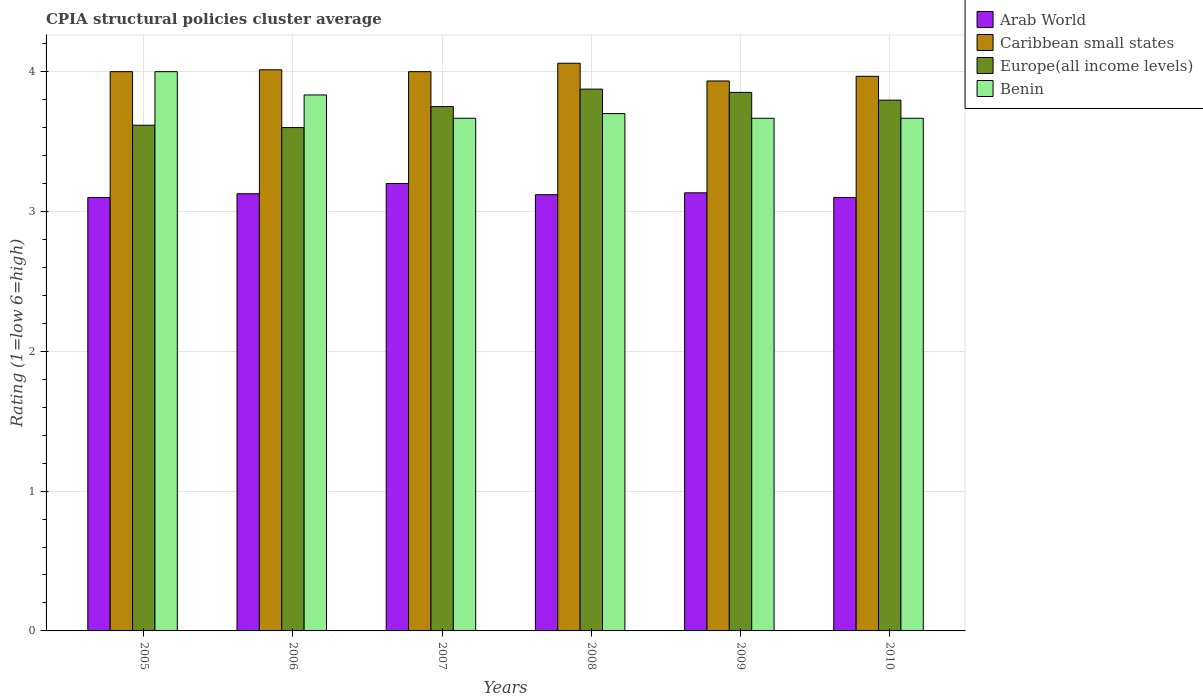How many different coloured bars are there?
Your answer should be very brief. 4. How many groups of bars are there?
Make the answer very short. 6. Are the number of bars per tick equal to the number of legend labels?
Keep it short and to the point. Yes. Are the number of bars on each tick of the X-axis equal?
Give a very brief answer. Yes. What is the label of the 2nd group of bars from the left?
Provide a succinct answer. 2006. In how many cases, is the number of bars for a given year not equal to the number of legend labels?
Your response must be concise. 0. Across all years, what is the maximum CPIA rating in Caribbean small states?
Offer a terse response. 4.06. Across all years, what is the minimum CPIA rating in Europe(all income levels)?
Provide a short and direct response. 3.6. In which year was the CPIA rating in Caribbean small states maximum?
Make the answer very short. 2008. In which year was the CPIA rating in Arab World minimum?
Offer a terse response. 2005. What is the total CPIA rating in Benin in the graph?
Provide a short and direct response. 22.53. What is the difference between the CPIA rating in Europe(all income levels) in 2005 and that in 2008?
Give a very brief answer. -0.26. What is the difference between the CPIA rating in Benin in 2005 and the CPIA rating in Arab World in 2009?
Ensure brevity in your answer.  0.87. What is the average CPIA rating in Europe(all income levels) per year?
Provide a succinct answer. 3.75. In the year 2008, what is the difference between the CPIA rating in Caribbean small states and CPIA rating in Benin?
Provide a succinct answer. 0.36. What is the ratio of the CPIA rating in Benin in 2005 to that in 2006?
Give a very brief answer. 1.04. What is the difference between the highest and the second highest CPIA rating in Europe(all income levels)?
Offer a very short reply. 0.02. What is the difference between the highest and the lowest CPIA rating in Caribbean small states?
Keep it short and to the point. 0.13. Is the sum of the CPIA rating in Caribbean small states in 2009 and 2010 greater than the maximum CPIA rating in Europe(all income levels) across all years?
Ensure brevity in your answer.  Yes. Is it the case that in every year, the sum of the CPIA rating in Benin and CPIA rating in Arab World is greater than the sum of CPIA rating in Europe(all income levels) and CPIA rating in Caribbean small states?
Give a very brief answer. No. What does the 4th bar from the left in 2005 represents?
Keep it short and to the point. Benin. What does the 4th bar from the right in 2006 represents?
Your response must be concise. Arab World. Is it the case that in every year, the sum of the CPIA rating in Arab World and CPIA rating in Europe(all income levels) is greater than the CPIA rating in Caribbean small states?
Offer a terse response. Yes. What is the difference between two consecutive major ticks on the Y-axis?
Ensure brevity in your answer.  1. Does the graph contain any zero values?
Your response must be concise. No. Does the graph contain grids?
Your answer should be very brief. Yes. Where does the legend appear in the graph?
Offer a very short reply. Top right. How many legend labels are there?
Make the answer very short. 4. How are the legend labels stacked?
Offer a very short reply. Vertical. What is the title of the graph?
Keep it short and to the point. CPIA structural policies cluster average. What is the label or title of the X-axis?
Provide a short and direct response. Years. What is the Rating (1=low 6=high) of Arab World in 2005?
Your answer should be compact. 3.1. What is the Rating (1=low 6=high) in Europe(all income levels) in 2005?
Provide a short and direct response. 3.62. What is the Rating (1=low 6=high) in Arab World in 2006?
Give a very brief answer. 3.13. What is the Rating (1=low 6=high) in Caribbean small states in 2006?
Your answer should be compact. 4.01. What is the Rating (1=low 6=high) of Benin in 2006?
Your response must be concise. 3.83. What is the Rating (1=low 6=high) in Caribbean small states in 2007?
Offer a very short reply. 4. What is the Rating (1=low 6=high) of Europe(all income levels) in 2007?
Your answer should be very brief. 3.75. What is the Rating (1=low 6=high) in Benin in 2007?
Make the answer very short. 3.67. What is the Rating (1=low 6=high) of Arab World in 2008?
Keep it short and to the point. 3.12. What is the Rating (1=low 6=high) of Caribbean small states in 2008?
Give a very brief answer. 4.06. What is the Rating (1=low 6=high) of Europe(all income levels) in 2008?
Provide a succinct answer. 3.88. What is the Rating (1=low 6=high) of Arab World in 2009?
Provide a succinct answer. 3.13. What is the Rating (1=low 6=high) in Caribbean small states in 2009?
Give a very brief answer. 3.93. What is the Rating (1=low 6=high) in Europe(all income levels) in 2009?
Offer a very short reply. 3.85. What is the Rating (1=low 6=high) in Benin in 2009?
Provide a succinct answer. 3.67. What is the Rating (1=low 6=high) in Caribbean small states in 2010?
Your response must be concise. 3.97. What is the Rating (1=low 6=high) in Europe(all income levels) in 2010?
Offer a terse response. 3.8. What is the Rating (1=low 6=high) in Benin in 2010?
Make the answer very short. 3.67. Across all years, what is the maximum Rating (1=low 6=high) of Caribbean small states?
Make the answer very short. 4.06. Across all years, what is the maximum Rating (1=low 6=high) of Europe(all income levels)?
Ensure brevity in your answer.  3.88. Across all years, what is the maximum Rating (1=low 6=high) in Benin?
Your answer should be compact. 4. Across all years, what is the minimum Rating (1=low 6=high) in Caribbean small states?
Give a very brief answer. 3.93. Across all years, what is the minimum Rating (1=low 6=high) in Europe(all income levels)?
Provide a succinct answer. 3.6. Across all years, what is the minimum Rating (1=low 6=high) of Benin?
Offer a very short reply. 3.67. What is the total Rating (1=low 6=high) of Arab World in the graph?
Your response must be concise. 18.78. What is the total Rating (1=low 6=high) in Caribbean small states in the graph?
Ensure brevity in your answer.  23.97. What is the total Rating (1=low 6=high) in Europe(all income levels) in the graph?
Offer a very short reply. 22.49. What is the total Rating (1=low 6=high) of Benin in the graph?
Give a very brief answer. 22.53. What is the difference between the Rating (1=low 6=high) in Arab World in 2005 and that in 2006?
Give a very brief answer. -0.03. What is the difference between the Rating (1=low 6=high) of Caribbean small states in 2005 and that in 2006?
Provide a succinct answer. -0.01. What is the difference between the Rating (1=low 6=high) in Europe(all income levels) in 2005 and that in 2006?
Your answer should be compact. 0.02. What is the difference between the Rating (1=low 6=high) of Europe(all income levels) in 2005 and that in 2007?
Offer a terse response. -0.13. What is the difference between the Rating (1=low 6=high) in Benin in 2005 and that in 2007?
Ensure brevity in your answer.  0.33. What is the difference between the Rating (1=low 6=high) in Arab World in 2005 and that in 2008?
Your answer should be very brief. -0.02. What is the difference between the Rating (1=low 6=high) in Caribbean small states in 2005 and that in 2008?
Provide a succinct answer. -0.06. What is the difference between the Rating (1=low 6=high) in Europe(all income levels) in 2005 and that in 2008?
Offer a terse response. -0.26. What is the difference between the Rating (1=low 6=high) in Benin in 2005 and that in 2008?
Provide a succinct answer. 0.3. What is the difference between the Rating (1=low 6=high) of Arab World in 2005 and that in 2009?
Your response must be concise. -0.03. What is the difference between the Rating (1=low 6=high) of Caribbean small states in 2005 and that in 2009?
Offer a very short reply. 0.07. What is the difference between the Rating (1=low 6=high) in Europe(all income levels) in 2005 and that in 2009?
Make the answer very short. -0.24. What is the difference between the Rating (1=low 6=high) in Benin in 2005 and that in 2009?
Offer a very short reply. 0.33. What is the difference between the Rating (1=low 6=high) of Arab World in 2005 and that in 2010?
Ensure brevity in your answer.  0. What is the difference between the Rating (1=low 6=high) in Caribbean small states in 2005 and that in 2010?
Provide a succinct answer. 0.03. What is the difference between the Rating (1=low 6=high) of Europe(all income levels) in 2005 and that in 2010?
Keep it short and to the point. -0.18. What is the difference between the Rating (1=low 6=high) of Arab World in 2006 and that in 2007?
Your answer should be compact. -0.07. What is the difference between the Rating (1=low 6=high) of Caribbean small states in 2006 and that in 2007?
Your answer should be very brief. 0.01. What is the difference between the Rating (1=low 6=high) of Europe(all income levels) in 2006 and that in 2007?
Offer a terse response. -0.15. What is the difference between the Rating (1=low 6=high) in Arab World in 2006 and that in 2008?
Provide a short and direct response. 0.01. What is the difference between the Rating (1=low 6=high) of Caribbean small states in 2006 and that in 2008?
Give a very brief answer. -0.05. What is the difference between the Rating (1=low 6=high) in Europe(all income levels) in 2006 and that in 2008?
Offer a terse response. -0.28. What is the difference between the Rating (1=low 6=high) of Benin in 2006 and that in 2008?
Your response must be concise. 0.13. What is the difference between the Rating (1=low 6=high) in Arab World in 2006 and that in 2009?
Your response must be concise. -0.01. What is the difference between the Rating (1=low 6=high) of Europe(all income levels) in 2006 and that in 2009?
Offer a very short reply. -0.25. What is the difference between the Rating (1=low 6=high) of Arab World in 2006 and that in 2010?
Keep it short and to the point. 0.03. What is the difference between the Rating (1=low 6=high) in Caribbean small states in 2006 and that in 2010?
Provide a short and direct response. 0.05. What is the difference between the Rating (1=low 6=high) in Europe(all income levels) in 2006 and that in 2010?
Offer a very short reply. -0.2. What is the difference between the Rating (1=low 6=high) in Arab World in 2007 and that in 2008?
Your answer should be very brief. 0.08. What is the difference between the Rating (1=low 6=high) of Caribbean small states in 2007 and that in 2008?
Offer a terse response. -0.06. What is the difference between the Rating (1=low 6=high) of Europe(all income levels) in 2007 and that in 2008?
Make the answer very short. -0.12. What is the difference between the Rating (1=low 6=high) of Benin in 2007 and that in 2008?
Give a very brief answer. -0.03. What is the difference between the Rating (1=low 6=high) of Arab World in 2007 and that in 2009?
Ensure brevity in your answer.  0.07. What is the difference between the Rating (1=low 6=high) of Caribbean small states in 2007 and that in 2009?
Offer a very short reply. 0.07. What is the difference between the Rating (1=low 6=high) of Europe(all income levels) in 2007 and that in 2009?
Offer a very short reply. -0.1. What is the difference between the Rating (1=low 6=high) of Europe(all income levels) in 2007 and that in 2010?
Offer a terse response. -0.05. What is the difference between the Rating (1=low 6=high) in Benin in 2007 and that in 2010?
Your answer should be compact. 0. What is the difference between the Rating (1=low 6=high) in Arab World in 2008 and that in 2009?
Offer a very short reply. -0.01. What is the difference between the Rating (1=low 6=high) of Caribbean small states in 2008 and that in 2009?
Offer a very short reply. 0.13. What is the difference between the Rating (1=low 6=high) of Europe(all income levels) in 2008 and that in 2009?
Provide a succinct answer. 0.02. What is the difference between the Rating (1=low 6=high) in Caribbean small states in 2008 and that in 2010?
Ensure brevity in your answer.  0.09. What is the difference between the Rating (1=low 6=high) of Europe(all income levels) in 2008 and that in 2010?
Ensure brevity in your answer.  0.08. What is the difference between the Rating (1=low 6=high) of Benin in 2008 and that in 2010?
Ensure brevity in your answer.  0.03. What is the difference between the Rating (1=low 6=high) in Arab World in 2009 and that in 2010?
Your answer should be very brief. 0.03. What is the difference between the Rating (1=low 6=high) in Caribbean small states in 2009 and that in 2010?
Ensure brevity in your answer.  -0.03. What is the difference between the Rating (1=low 6=high) of Europe(all income levels) in 2009 and that in 2010?
Keep it short and to the point. 0.06. What is the difference between the Rating (1=low 6=high) of Arab World in 2005 and the Rating (1=low 6=high) of Caribbean small states in 2006?
Your answer should be compact. -0.91. What is the difference between the Rating (1=low 6=high) in Arab World in 2005 and the Rating (1=low 6=high) in Europe(all income levels) in 2006?
Your answer should be compact. -0.5. What is the difference between the Rating (1=low 6=high) in Arab World in 2005 and the Rating (1=low 6=high) in Benin in 2006?
Keep it short and to the point. -0.73. What is the difference between the Rating (1=low 6=high) of Caribbean small states in 2005 and the Rating (1=low 6=high) of Europe(all income levels) in 2006?
Keep it short and to the point. 0.4. What is the difference between the Rating (1=low 6=high) in Europe(all income levels) in 2005 and the Rating (1=low 6=high) in Benin in 2006?
Provide a succinct answer. -0.22. What is the difference between the Rating (1=low 6=high) of Arab World in 2005 and the Rating (1=low 6=high) of Europe(all income levels) in 2007?
Offer a very short reply. -0.65. What is the difference between the Rating (1=low 6=high) of Arab World in 2005 and the Rating (1=low 6=high) of Benin in 2007?
Provide a succinct answer. -0.57. What is the difference between the Rating (1=low 6=high) in Caribbean small states in 2005 and the Rating (1=low 6=high) in Europe(all income levels) in 2007?
Offer a terse response. 0.25. What is the difference between the Rating (1=low 6=high) of Europe(all income levels) in 2005 and the Rating (1=low 6=high) of Benin in 2007?
Provide a short and direct response. -0.05. What is the difference between the Rating (1=low 6=high) of Arab World in 2005 and the Rating (1=low 6=high) of Caribbean small states in 2008?
Provide a succinct answer. -0.96. What is the difference between the Rating (1=low 6=high) in Arab World in 2005 and the Rating (1=low 6=high) in Europe(all income levels) in 2008?
Keep it short and to the point. -0.78. What is the difference between the Rating (1=low 6=high) of Arab World in 2005 and the Rating (1=low 6=high) of Benin in 2008?
Keep it short and to the point. -0.6. What is the difference between the Rating (1=low 6=high) of Caribbean small states in 2005 and the Rating (1=low 6=high) of Benin in 2008?
Offer a terse response. 0.3. What is the difference between the Rating (1=low 6=high) of Europe(all income levels) in 2005 and the Rating (1=low 6=high) of Benin in 2008?
Your response must be concise. -0.08. What is the difference between the Rating (1=low 6=high) of Arab World in 2005 and the Rating (1=low 6=high) of Caribbean small states in 2009?
Give a very brief answer. -0.83. What is the difference between the Rating (1=low 6=high) of Arab World in 2005 and the Rating (1=low 6=high) of Europe(all income levels) in 2009?
Give a very brief answer. -0.75. What is the difference between the Rating (1=low 6=high) of Arab World in 2005 and the Rating (1=low 6=high) of Benin in 2009?
Your response must be concise. -0.57. What is the difference between the Rating (1=low 6=high) of Caribbean small states in 2005 and the Rating (1=low 6=high) of Europe(all income levels) in 2009?
Provide a succinct answer. 0.15. What is the difference between the Rating (1=low 6=high) of Arab World in 2005 and the Rating (1=low 6=high) of Caribbean small states in 2010?
Provide a short and direct response. -0.87. What is the difference between the Rating (1=low 6=high) of Arab World in 2005 and the Rating (1=low 6=high) of Europe(all income levels) in 2010?
Provide a short and direct response. -0.7. What is the difference between the Rating (1=low 6=high) in Arab World in 2005 and the Rating (1=low 6=high) in Benin in 2010?
Your answer should be compact. -0.57. What is the difference between the Rating (1=low 6=high) in Caribbean small states in 2005 and the Rating (1=low 6=high) in Europe(all income levels) in 2010?
Offer a terse response. 0.2. What is the difference between the Rating (1=low 6=high) of Caribbean small states in 2005 and the Rating (1=low 6=high) of Benin in 2010?
Provide a succinct answer. 0.33. What is the difference between the Rating (1=low 6=high) in Europe(all income levels) in 2005 and the Rating (1=low 6=high) in Benin in 2010?
Provide a short and direct response. -0.05. What is the difference between the Rating (1=low 6=high) of Arab World in 2006 and the Rating (1=low 6=high) of Caribbean small states in 2007?
Your answer should be very brief. -0.87. What is the difference between the Rating (1=low 6=high) in Arab World in 2006 and the Rating (1=low 6=high) in Europe(all income levels) in 2007?
Your answer should be very brief. -0.62. What is the difference between the Rating (1=low 6=high) of Arab World in 2006 and the Rating (1=low 6=high) of Benin in 2007?
Make the answer very short. -0.54. What is the difference between the Rating (1=low 6=high) in Caribbean small states in 2006 and the Rating (1=low 6=high) in Europe(all income levels) in 2007?
Provide a succinct answer. 0.26. What is the difference between the Rating (1=low 6=high) in Caribbean small states in 2006 and the Rating (1=low 6=high) in Benin in 2007?
Offer a terse response. 0.35. What is the difference between the Rating (1=low 6=high) of Europe(all income levels) in 2006 and the Rating (1=low 6=high) of Benin in 2007?
Offer a very short reply. -0.07. What is the difference between the Rating (1=low 6=high) in Arab World in 2006 and the Rating (1=low 6=high) in Caribbean small states in 2008?
Ensure brevity in your answer.  -0.93. What is the difference between the Rating (1=low 6=high) in Arab World in 2006 and the Rating (1=low 6=high) in Europe(all income levels) in 2008?
Ensure brevity in your answer.  -0.75. What is the difference between the Rating (1=low 6=high) of Arab World in 2006 and the Rating (1=low 6=high) of Benin in 2008?
Offer a very short reply. -0.57. What is the difference between the Rating (1=low 6=high) of Caribbean small states in 2006 and the Rating (1=low 6=high) of Europe(all income levels) in 2008?
Offer a terse response. 0.14. What is the difference between the Rating (1=low 6=high) of Caribbean small states in 2006 and the Rating (1=low 6=high) of Benin in 2008?
Offer a very short reply. 0.31. What is the difference between the Rating (1=low 6=high) of Arab World in 2006 and the Rating (1=low 6=high) of Caribbean small states in 2009?
Your answer should be compact. -0.81. What is the difference between the Rating (1=low 6=high) of Arab World in 2006 and the Rating (1=low 6=high) of Europe(all income levels) in 2009?
Provide a short and direct response. -0.73. What is the difference between the Rating (1=low 6=high) in Arab World in 2006 and the Rating (1=low 6=high) in Benin in 2009?
Ensure brevity in your answer.  -0.54. What is the difference between the Rating (1=low 6=high) of Caribbean small states in 2006 and the Rating (1=low 6=high) of Europe(all income levels) in 2009?
Give a very brief answer. 0.16. What is the difference between the Rating (1=low 6=high) of Caribbean small states in 2006 and the Rating (1=low 6=high) of Benin in 2009?
Your response must be concise. 0.35. What is the difference between the Rating (1=low 6=high) in Europe(all income levels) in 2006 and the Rating (1=low 6=high) in Benin in 2009?
Provide a short and direct response. -0.07. What is the difference between the Rating (1=low 6=high) of Arab World in 2006 and the Rating (1=low 6=high) of Caribbean small states in 2010?
Your response must be concise. -0.84. What is the difference between the Rating (1=low 6=high) of Arab World in 2006 and the Rating (1=low 6=high) of Europe(all income levels) in 2010?
Your response must be concise. -0.67. What is the difference between the Rating (1=low 6=high) in Arab World in 2006 and the Rating (1=low 6=high) in Benin in 2010?
Your response must be concise. -0.54. What is the difference between the Rating (1=low 6=high) of Caribbean small states in 2006 and the Rating (1=low 6=high) of Europe(all income levels) in 2010?
Make the answer very short. 0.22. What is the difference between the Rating (1=low 6=high) in Caribbean small states in 2006 and the Rating (1=low 6=high) in Benin in 2010?
Your answer should be very brief. 0.35. What is the difference between the Rating (1=low 6=high) in Europe(all income levels) in 2006 and the Rating (1=low 6=high) in Benin in 2010?
Offer a terse response. -0.07. What is the difference between the Rating (1=low 6=high) in Arab World in 2007 and the Rating (1=low 6=high) in Caribbean small states in 2008?
Give a very brief answer. -0.86. What is the difference between the Rating (1=low 6=high) in Arab World in 2007 and the Rating (1=low 6=high) in Europe(all income levels) in 2008?
Your answer should be compact. -0.68. What is the difference between the Rating (1=low 6=high) in Arab World in 2007 and the Rating (1=low 6=high) in Benin in 2008?
Offer a very short reply. -0.5. What is the difference between the Rating (1=low 6=high) in Arab World in 2007 and the Rating (1=low 6=high) in Caribbean small states in 2009?
Provide a succinct answer. -0.73. What is the difference between the Rating (1=low 6=high) in Arab World in 2007 and the Rating (1=low 6=high) in Europe(all income levels) in 2009?
Keep it short and to the point. -0.65. What is the difference between the Rating (1=low 6=high) of Arab World in 2007 and the Rating (1=low 6=high) of Benin in 2009?
Your response must be concise. -0.47. What is the difference between the Rating (1=low 6=high) in Caribbean small states in 2007 and the Rating (1=low 6=high) in Europe(all income levels) in 2009?
Provide a short and direct response. 0.15. What is the difference between the Rating (1=low 6=high) in Caribbean small states in 2007 and the Rating (1=low 6=high) in Benin in 2009?
Your answer should be compact. 0.33. What is the difference between the Rating (1=low 6=high) of Europe(all income levels) in 2007 and the Rating (1=low 6=high) of Benin in 2009?
Ensure brevity in your answer.  0.08. What is the difference between the Rating (1=low 6=high) in Arab World in 2007 and the Rating (1=low 6=high) in Caribbean small states in 2010?
Your response must be concise. -0.77. What is the difference between the Rating (1=low 6=high) of Arab World in 2007 and the Rating (1=low 6=high) of Europe(all income levels) in 2010?
Ensure brevity in your answer.  -0.6. What is the difference between the Rating (1=low 6=high) in Arab World in 2007 and the Rating (1=low 6=high) in Benin in 2010?
Give a very brief answer. -0.47. What is the difference between the Rating (1=low 6=high) of Caribbean small states in 2007 and the Rating (1=low 6=high) of Europe(all income levels) in 2010?
Keep it short and to the point. 0.2. What is the difference between the Rating (1=low 6=high) in Europe(all income levels) in 2007 and the Rating (1=low 6=high) in Benin in 2010?
Ensure brevity in your answer.  0.08. What is the difference between the Rating (1=low 6=high) of Arab World in 2008 and the Rating (1=low 6=high) of Caribbean small states in 2009?
Your answer should be compact. -0.81. What is the difference between the Rating (1=low 6=high) of Arab World in 2008 and the Rating (1=low 6=high) of Europe(all income levels) in 2009?
Your answer should be compact. -0.73. What is the difference between the Rating (1=low 6=high) of Arab World in 2008 and the Rating (1=low 6=high) of Benin in 2009?
Provide a short and direct response. -0.55. What is the difference between the Rating (1=low 6=high) of Caribbean small states in 2008 and the Rating (1=low 6=high) of Europe(all income levels) in 2009?
Provide a short and direct response. 0.21. What is the difference between the Rating (1=low 6=high) in Caribbean small states in 2008 and the Rating (1=low 6=high) in Benin in 2009?
Ensure brevity in your answer.  0.39. What is the difference between the Rating (1=low 6=high) in Europe(all income levels) in 2008 and the Rating (1=low 6=high) in Benin in 2009?
Make the answer very short. 0.21. What is the difference between the Rating (1=low 6=high) of Arab World in 2008 and the Rating (1=low 6=high) of Caribbean small states in 2010?
Your answer should be compact. -0.85. What is the difference between the Rating (1=low 6=high) of Arab World in 2008 and the Rating (1=low 6=high) of Europe(all income levels) in 2010?
Ensure brevity in your answer.  -0.68. What is the difference between the Rating (1=low 6=high) in Arab World in 2008 and the Rating (1=low 6=high) in Benin in 2010?
Offer a terse response. -0.55. What is the difference between the Rating (1=low 6=high) of Caribbean small states in 2008 and the Rating (1=low 6=high) of Europe(all income levels) in 2010?
Offer a terse response. 0.26. What is the difference between the Rating (1=low 6=high) of Caribbean small states in 2008 and the Rating (1=low 6=high) of Benin in 2010?
Your answer should be very brief. 0.39. What is the difference between the Rating (1=low 6=high) of Europe(all income levels) in 2008 and the Rating (1=low 6=high) of Benin in 2010?
Keep it short and to the point. 0.21. What is the difference between the Rating (1=low 6=high) of Arab World in 2009 and the Rating (1=low 6=high) of Europe(all income levels) in 2010?
Offer a terse response. -0.66. What is the difference between the Rating (1=low 6=high) of Arab World in 2009 and the Rating (1=low 6=high) of Benin in 2010?
Give a very brief answer. -0.53. What is the difference between the Rating (1=low 6=high) in Caribbean small states in 2009 and the Rating (1=low 6=high) in Europe(all income levels) in 2010?
Your response must be concise. 0.14. What is the difference between the Rating (1=low 6=high) in Caribbean small states in 2009 and the Rating (1=low 6=high) in Benin in 2010?
Make the answer very short. 0.27. What is the difference between the Rating (1=low 6=high) of Europe(all income levels) in 2009 and the Rating (1=low 6=high) of Benin in 2010?
Offer a very short reply. 0.19. What is the average Rating (1=low 6=high) in Arab World per year?
Your answer should be very brief. 3.13. What is the average Rating (1=low 6=high) of Caribbean small states per year?
Your answer should be very brief. 4. What is the average Rating (1=low 6=high) of Europe(all income levels) per year?
Your answer should be very brief. 3.75. What is the average Rating (1=low 6=high) of Benin per year?
Make the answer very short. 3.76. In the year 2005, what is the difference between the Rating (1=low 6=high) of Arab World and Rating (1=low 6=high) of Europe(all income levels)?
Your answer should be very brief. -0.52. In the year 2005, what is the difference between the Rating (1=low 6=high) of Arab World and Rating (1=low 6=high) of Benin?
Provide a short and direct response. -0.9. In the year 2005, what is the difference between the Rating (1=low 6=high) in Caribbean small states and Rating (1=low 6=high) in Europe(all income levels)?
Your answer should be compact. 0.38. In the year 2005, what is the difference between the Rating (1=low 6=high) of Europe(all income levels) and Rating (1=low 6=high) of Benin?
Give a very brief answer. -0.38. In the year 2006, what is the difference between the Rating (1=low 6=high) in Arab World and Rating (1=low 6=high) in Caribbean small states?
Keep it short and to the point. -0.89. In the year 2006, what is the difference between the Rating (1=low 6=high) in Arab World and Rating (1=low 6=high) in Europe(all income levels)?
Your response must be concise. -0.47. In the year 2006, what is the difference between the Rating (1=low 6=high) of Arab World and Rating (1=low 6=high) of Benin?
Ensure brevity in your answer.  -0.71. In the year 2006, what is the difference between the Rating (1=low 6=high) of Caribbean small states and Rating (1=low 6=high) of Europe(all income levels)?
Offer a very short reply. 0.41. In the year 2006, what is the difference between the Rating (1=low 6=high) of Caribbean small states and Rating (1=low 6=high) of Benin?
Offer a very short reply. 0.18. In the year 2006, what is the difference between the Rating (1=low 6=high) in Europe(all income levels) and Rating (1=low 6=high) in Benin?
Provide a short and direct response. -0.23. In the year 2007, what is the difference between the Rating (1=low 6=high) in Arab World and Rating (1=low 6=high) in Europe(all income levels)?
Ensure brevity in your answer.  -0.55. In the year 2007, what is the difference between the Rating (1=low 6=high) of Arab World and Rating (1=low 6=high) of Benin?
Keep it short and to the point. -0.47. In the year 2007, what is the difference between the Rating (1=low 6=high) in Caribbean small states and Rating (1=low 6=high) in Benin?
Your response must be concise. 0.33. In the year 2007, what is the difference between the Rating (1=low 6=high) in Europe(all income levels) and Rating (1=low 6=high) in Benin?
Your answer should be compact. 0.08. In the year 2008, what is the difference between the Rating (1=low 6=high) in Arab World and Rating (1=low 6=high) in Caribbean small states?
Offer a terse response. -0.94. In the year 2008, what is the difference between the Rating (1=low 6=high) of Arab World and Rating (1=low 6=high) of Europe(all income levels)?
Offer a very short reply. -0.76. In the year 2008, what is the difference between the Rating (1=low 6=high) in Arab World and Rating (1=low 6=high) in Benin?
Offer a very short reply. -0.58. In the year 2008, what is the difference between the Rating (1=low 6=high) of Caribbean small states and Rating (1=low 6=high) of Europe(all income levels)?
Provide a short and direct response. 0.18. In the year 2008, what is the difference between the Rating (1=low 6=high) of Caribbean small states and Rating (1=low 6=high) of Benin?
Ensure brevity in your answer.  0.36. In the year 2008, what is the difference between the Rating (1=low 6=high) in Europe(all income levels) and Rating (1=low 6=high) in Benin?
Your response must be concise. 0.17. In the year 2009, what is the difference between the Rating (1=low 6=high) of Arab World and Rating (1=low 6=high) of Europe(all income levels)?
Your response must be concise. -0.72. In the year 2009, what is the difference between the Rating (1=low 6=high) in Arab World and Rating (1=low 6=high) in Benin?
Your answer should be compact. -0.53. In the year 2009, what is the difference between the Rating (1=low 6=high) of Caribbean small states and Rating (1=low 6=high) of Europe(all income levels)?
Offer a very short reply. 0.08. In the year 2009, what is the difference between the Rating (1=low 6=high) of Caribbean small states and Rating (1=low 6=high) of Benin?
Give a very brief answer. 0.27. In the year 2009, what is the difference between the Rating (1=low 6=high) of Europe(all income levels) and Rating (1=low 6=high) of Benin?
Your response must be concise. 0.19. In the year 2010, what is the difference between the Rating (1=low 6=high) of Arab World and Rating (1=low 6=high) of Caribbean small states?
Your answer should be very brief. -0.87. In the year 2010, what is the difference between the Rating (1=low 6=high) of Arab World and Rating (1=low 6=high) of Europe(all income levels)?
Provide a short and direct response. -0.7. In the year 2010, what is the difference between the Rating (1=low 6=high) in Arab World and Rating (1=low 6=high) in Benin?
Give a very brief answer. -0.57. In the year 2010, what is the difference between the Rating (1=low 6=high) in Caribbean small states and Rating (1=low 6=high) in Europe(all income levels)?
Give a very brief answer. 0.17. In the year 2010, what is the difference between the Rating (1=low 6=high) of Caribbean small states and Rating (1=low 6=high) of Benin?
Your response must be concise. 0.3. In the year 2010, what is the difference between the Rating (1=low 6=high) of Europe(all income levels) and Rating (1=low 6=high) of Benin?
Your answer should be very brief. 0.13. What is the ratio of the Rating (1=low 6=high) of Benin in 2005 to that in 2006?
Offer a very short reply. 1.04. What is the ratio of the Rating (1=low 6=high) of Arab World in 2005 to that in 2007?
Ensure brevity in your answer.  0.97. What is the ratio of the Rating (1=low 6=high) in Caribbean small states in 2005 to that in 2007?
Your answer should be compact. 1. What is the ratio of the Rating (1=low 6=high) of Europe(all income levels) in 2005 to that in 2007?
Make the answer very short. 0.96. What is the ratio of the Rating (1=low 6=high) of Arab World in 2005 to that in 2008?
Make the answer very short. 0.99. What is the ratio of the Rating (1=low 6=high) of Caribbean small states in 2005 to that in 2008?
Offer a terse response. 0.99. What is the ratio of the Rating (1=low 6=high) of Europe(all income levels) in 2005 to that in 2008?
Your answer should be very brief. 0.93. What is the ratio of the Rating (1=low 6=high) of Benin in 2005 to that in 2008?
Provide a succinct answer. 1.08. What is the ratio of the Rating (1=low 6=high) in Arab World in 2005 to that in 2009?
Provide a short and direct response. 0.99. What is the ratio of the Rating (1=low 6=high) in Caribbean small states in 2005 to that in 2009?
Give a very brief answer. 1.02. What is the ratio of the Rating (1=low 6=high) in Europe(all income levels) in 2005 to that in 2009?
Ensure brevity in your answer.  0.94. What is the ratio of the Rating (1=low 6=high) in Benin in 2005 to that in 2009?
Provide a short and direct response. 1.09. What is the ratio of the Rating (1=low 6=high) of Caribbean small states in 2005 to that in 2010?
Your response must be concise. 1.01. What is the ratio of the Rating (1=low 6=high) in Europe(all income levels) in 2005 to that in 2010?
Provide a short and direct response. 0.95. What is the ratio of the Rating (1=low 6=high) in Benin in 2005 to that in 2010?
Your response must be concise. 1.09. What is the ratio of the Rating (1=low 6=high) in Arab World in 2006 to that in 2007?
Your answer should be very brief. 0.98. What is the ratio of the Rating (1=low 6=high) in Europe(all income levels) in 2006 to that in 2007?
Give a very brief answer. 0.96. What is the ratio of the Rating (1=low 6=high) of Benin in 2006 to that in 2007?
Provide a succinct answer. 1.05. What is the ratio of the Rating (1=low 6=high) in Arab World in 2006 to that in 2008?
Your response must be concise. 1. What is the ratio of the Rating (1=low 6=high) in Caribbean small states in 2006 to that in 2008?
Provide a succinct answer. 0.99. What is the ratio of the Rating (1=low 6=high) of Europe(all income levels) in 2006 to that in 2008?
Keep it short and to the point. 0.93. What is the ratio of the Rating (1=low 6=high) in Benin in 2006 to that in 2008?
Offer a very short reply. 1.04. What is the ratio of the Rating (1=low 6=high) of Caribbean small states in 2006 to that in 2009?
Provide a short and direct response. 1.02. What is the ratio of the Rating (1=low 6=high) in Europe(all income levels) in 2006 to that in 2009?
Make the answer very short. 0.93. What is the ratio of the Rating (1=low 6=high) of Benin in 2006 to that in 2009?
Provide a succinct answer. 1.05. What is the ratio of the Rating (1=low 6=high) of Arab World in 2006 to that in 2010?
Your answer should be compact. 1.01. What is the ratio of the Rating (1=low 6=high) of Caribbean small states in 2006 to that in 2010?
Keep it short and to the point. 1.01. What is the ratio of the Rating (1=low 6=high) of Europe(all income levels) in 2006 to that in 2010?
Keep it short and to the point. 0.95. What is the ratio of the Rating (1=low 6=high) in Benin in 2006 to that in 2010?
Offer a terse response. 1.05. What is the ratio of the Rating (1=low 6=high) in Arab World in 2007 to that in 2008?
Your response must be concise. 1.03. What is the ratio of the Rating (1=low 6=high) in Caribbean small states in 2007 to that in 2008?
Make the answer very short. 0.99. What is the ratio of the Rating (1=low 6=high) of Benin in 2007 to that in 2008?
Your answer should be very brief. 0.99. What is the ratio of the Rating (1=low 6=high) in Arab World in 2007 to that in 2009?
Give a very brief answer. 1.02. What is the ratio of the Rating (1=low 6=high) of Caribbean small states in 2007 to that in 2009?
Provide a short and direct response. 1.02. What is the ratio of the Rating (1=low 6=high) of Europe(all income levels) in 2007 to that in 2009?
Give a very brief answer. 0.97. What is the ratio of the Rating (1=low 6=high) in Benin in 2007 to that in 2009?
Offer a very short reply. 1. What is the ratio of the Rating (1=low 6=high) in Arab World in 2007 to that in 2010?
Offer a very short reply. 1.03. What is the ratio of the Rating (1=low 6=high) in Caribbean small states in 2007 to that in 2010?
Your response must be concise. 1.01. What is the ratio of the Rating (1=low 6=high) in Europe(all income levels) in 2007 to that in 2010?
Your answer should be compact. 0.99. What is the ratio of the Rating (1=low 6=high) of Arab World in 2008 to that in 2009?
Provide a short and direct response. 1. What is the ratio of the Rating (1=low 6=high) in Caribbean small states in 2008 to that in 2009?
Your response must be concise. 1.03. What is the ratio of the Rating (1=low 6=high) in Benin in 2008 to that in 2009?
Keep it short and to the point. 1.01. What is the ratio of the Rating (1=low 6=high) in Arab World in 2008 to that in 2010?
Offer a terse response. 1.01. What is the ratio of the Rating (1=low 6=high) of Caribbean small states in 2008 to that in 2010?
Provide a short and direct response. 1.02. What is the ratio of the Rating (1=low 6=high) in Europe(all income levels) in 2008 to that in 2010?
Your answer should be very brief. 1.02. What is the ratio of the Rating (1=low 6=high) in Benin in 2008 to that in 2010?
Your answer should be very brief. 1.01. What is the ratio of the Rating (1=low 6=high) of Arab World in 2009 to that in 2010?
Ensure brevity in your answer.  1.01. What is the ratio of the Rating (1=low 6=high) of Europe(all income levels) in 2009 to that in 2010?
Provide a short and direct response. 1.01. What is the difference between the highest and the second highest Rating (1=low 6=high) in Arab World?
Make the answer very short. 0.07. What is the difference between the highest and the second highest Rating (1=low 6=high) of Caribbean small states?
Offer a terse response. 0.05. What is the difference between the highest and the second highest Rating (1=low 6=high) of Europe(all income levels)?
Provide a succinct answer. 0.02. What is the difference between the highest and the lowest Rating (1=low 6=high) of Caribbean small states?
Offer a very short reply. 0.13. What is the difference between the highest and the lowest Rating (1=low 6=high) of Europe(all income levels)?
Offer a terse response. 0.28. 